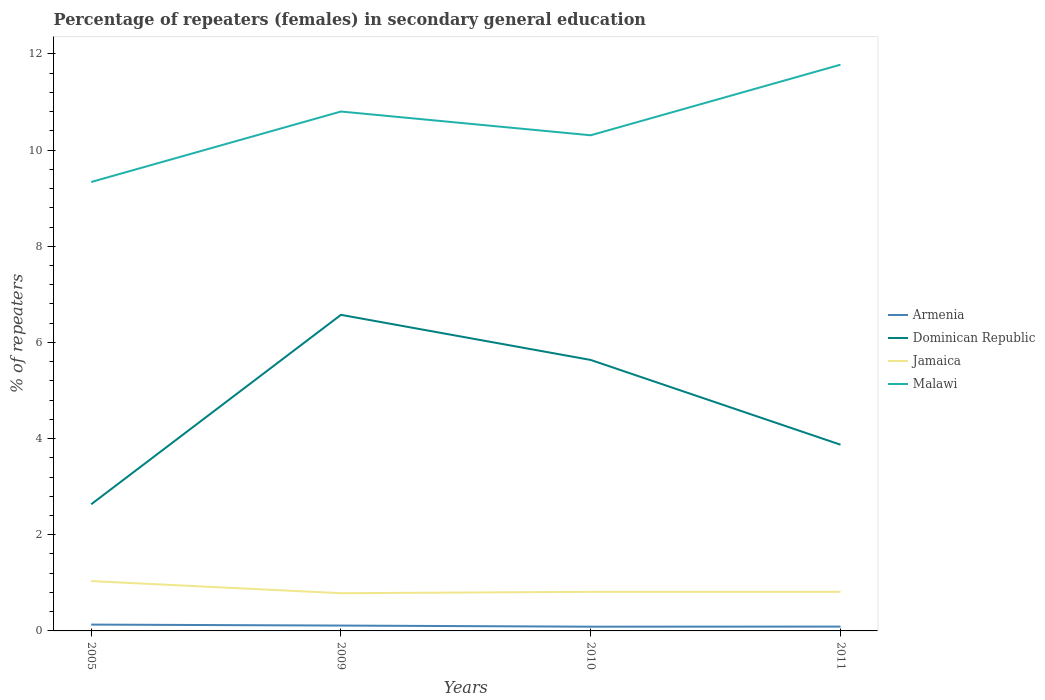Is the number of lines equal to the number of legend labels?
Your answer should be very brief. Yes. Across all years, what is the maximum percentage of female repeaters in Jamaica?
Your answer should be very brief. 0.78. What is the difference between the highest and the second highest percentage of female repeaters in Jamaica?
Provide a succinct answer. 0.25. What is the difference between the highest and the lowest percentage of female repeaters in Jamaica?
Make the answer very short. 1. Is the percentage of female repeaters in Dominican Republic strictly greater than the percentage of female repeaters in Malawi over the years?
Provide a short and direct response. Yes. How many lines are there?
Your answer should be compact. 4. What is the difference between two consecutive major ticks on the Y-axis?
Your answer should be compact. 2. Are the values on the major ticks of Y-axis written in scientific E-notation?
Offer a terse response. No. Does the graph contain grids?
Give a very brief answer. No. Where does the legend appear in the graph?
Make the answer very short. Center right. How many legend labels are there?
Provide a succinct answer. 4. What is the title of the graph?
Make the answer very short. Percentage of repeaters (females) in secondary general education. Does "Bosnia and Herzegovina" appear as one of the legend labels in the graph?
Provide a succinct answer. No. What is the label or title of the Y-axis?
Offer a very short reply. % of repeaters. What is the % of repeaters in Armenia in 2005?
Provide a succinct answer. 0.13. What is the % of repeaters of Dominican Republic in 2005?
Provide a short and direct response. 2.63. What is the % of repeaters in Jamaica in 2005?
Offer a terse response. 1.04. What is the % of repeaters in Malawi in 2005?
Your response must be concise. 9.34. What is the % of repeaters of Armenia in 2009?
Offer a terse response. 0.11. What is the % of repeaters of Dominican Republic in 2009?
Offer a very short reply. 6.57. What is the % of repeaters of Jamaica in 2009?
Keep it short and to the point. 0.78. What is the % of repeaters of Malawi in 2009?
Ensure brevity in your answer.  10.8. What is the % of repeaters in Armenia in 2010?
Keep it short and to the point. 0.09. What is the % of repeaters of Dominican Republic in 2010?
Your answer should be compact. 5.64. What is the % of repeaters of Jamaica in 2010?
Offer a very short reply. 0.81. What is the % of repeaters in Malawi in 2010?
Offer a terse response. 10.31. What is the % of repeaters of Armenia in 2011?
Your answer should be compact. 0.09. What is the % of repeaters in Dominican Republic in 2011?
Your answer should be very brief. 3.87. What is the % of repeaters in Jamaica in 2011?
Ensure brevity in your answer.  0.81. What is the % of repeaters of Malawi in 2011?
Keep it short and to the point. 11.78. Across all years, what is the maximum % of repeaters in Armenia?
Your response must be concise. 0.13. Across all years, what is the maximum % of repeaters in Dominican Republic?
Keep it short and to the point. 6.57. Across all years, what is the maximum % of repeaters of Jamaica?
Offer a very short reply. 1.04. Across all years, what is the maximum % of repeaters of Malawi?
Offer a very short reply. 11.78. Across all years, what is the minimum % of repeaters in Armenia?
Make the answer very short. 0.09. Across all years, what is the minimum % of repeaters in Dominican Republic?
Your answer should be very brief. 2.63. Across all years, what is the minimum % of repeaters in Jamaica?
Provide a succinct answer. 0.78. Across all years, what is the minimum % of repeaters of Malawi?
Your answer should be compact. 9.34. What is the total % of repeaters in Armenia in the graph?
Provide a succinct answer. 0.42. What is the total % of repeaters of Dominican Republic in the graph?
Make the answer very short. 18.72. What is the total % of repeaters in Jamaica in the graph?
Make the answer very short. 3.45. What is the total % of repeaters of Malawi in the graph?
Ensure brevity in your answer.  42.22. What is the difference between the % of repeaters in Dominican Republic in 2005 and that in 2009?
Offer a terse response. -3.94. What is the difference between the % of repeaters of Jamaica in 2005 and that in 2009?
Offer a very short reply. 0.25. What is the difference between the % of repeaters of Malawi in 2005 and that in 2009?
Make the answer very short. -1.47. What is the difference between the % of repeaters in Armenia in 2005 and that in 2010?
Provide a short and direct response. 0.04. What is the difference between the % of repeaters of Dominican Republic in 2005 and that in 2010?
Keep it short and to the point. -3. What is the difference between the % of repeaters of Jamaica in 2005 and that in 2010?
Make the answer very short. 0.22. What is the difference between the % of repeaters of Malawi in 2005 and that in 2010?
Make the answer very short. -0.97. What is the difference between the % of repeaters in Armenia in 2005 and that in 2011?
Ensure brevity in your answer.  0.04. What is the difference between the % of repeaters of Dominican Republic in 2005 and that in 2011?
Offer a very short reply. -1.24. What is the difference between the % of repeaters in Jamaica in 2005 and that in 2011?
Provide a short and direct response. 0.22. What is the difference between the % of repeaters in Malawi in 2005 and that in 2011?
Keep it short and to the point. -2.44. What is the difference between the % of repeaters of Armenia in 2009 and that in 2010?
Your response must be concise. 0.02. What is the difference between the % of repeaters in Dominican Republic in 2009 and that in 2010?
Your response must be concise. 0.94. What is the difference between the % of repeaters of Jamaica in 2009 and that in 2010?
Ensure brevity in your answer.  -0.03. What is the difference between the % of repeaters of Malawi in 2009 and that in 2010?
Your answer should be compact. 0.49. What is the difference between the % of repeaters of Armenia in 2009 and that in 2011?
Your answer should be compact. 0.02. What is the difference between the % of repeaters in Dominican Republic in 2009 and that in 2011?
Give a very brief answer. 2.7. What is the difference between the % of repeaters in Jamaica in 2009 and that in 2011?
Your answer should be compact. -0.03. What is the difference between the % of repeaters of Malawi in 2009 and that in 2011?
Your answer should be very brief. -0.97. What is the difference between the % of repeaters in Armenia in 2010 and that in 2011?
Provide a short and direct response. -0. What is the difference between the % of repeaters of Dominican Republic in 2010 and that in 2011?
Keep it short and to the point. 1.76. What is the difference between the % of repeaters in Jamaica in 2010 and that in 2011?
Your answer should be very brief. 0. What is the difference between the % of repeaters in Malawi in 2010 and that in 2011?
Your answer should be compact. -1.47. What is the difference between the % of repeaters of Armenia in 2005 and the % of repeaters of Dominican Republic in 2009?
Your answer should be very brief. -6.44. What is the difference between the % of repeaters of Armenia in 2005 and the % of repeaters of Jamaica in 2009?
Provide a succinct answer. -0.65. What is the difference between the % of repeaters of Armenia in 2005 and the % of repeaters of Malawi in 2009?
Provide a short and direct response. -10.67. What is the difference between the % of repeaters in Dominican Republic in 2005 and the % of repeaters in Jamaica in 2009?
Offer a terse response. 1.85. What is the difference between the % of repeaters in Dominican Republic in 2005 and the % of repeaters in Malawi in 2009?
Give a very brief answer. -8.17. What is the difference between the % of repeaters in Jamaica in 2005 and the % of repeaters in Malawi in 2009?
Keep it short and to the point. -9.77. What is the difference between the % of repeaters of Armenia in 2005 and the % of repeaters of Dominican Republic in 2010?
Give a very brief answer. -5.5. What is the difference between the % of repeaters in Armenia in 2005 and the % of repeaters in Jamaica in 2010?
Your answer should be compact. -0.68. What is the difference between the % of repeaters in Armenia in 2005 and the % of repeaters in Malawi in 2010?
Offer a terse response. -10.18. What is the difference between the % of repeaters of Dominican Republic in 2005 and the % of repeaters of Jamaica in 2010?
Ensure brevity in your answer.  1.82. What is the difference between the % of repeaters of Dominican Republic in 2005 and the % of repeaters of Malawi in 2010?
Your answer should be very brief. -7.67. What is the difference between the % of repeaters of Jamaica in 2005 and the % of repeaters of Malawi in 2010?
Ensure brevity in your answer.  -9.27. What is the difference between the % of repeaters in Armenia in 2005 and the % of repeaters in Dominican Republic in 2011?
Your answer should be compact. -3.74. What is the difference between the % of repeaters in Armenia in 2005 and the % of repeaters in Jamaica in 2011?
Offer a terse response. -0.68. What is the difference between the % of repeaters of Armenia in 2005 and the % of repeaters of Malawi in 2011?
Provide a succinct answer. -11.64. What is the difference between the % of repeaters of Dominican Republic in 2005 and the % of repeaters of Jamaica in 2011?
Offer a terse response. 1.82. What is the difference between the % of repeaters of Dominican Republic in 2005 and the % of repeaters of Malawi in 2011?
Make the answer very short. -9.14. What is the difference between the % of repeaters in Jamaica in 2005 and the % of repeaters in Malawi in 2011?
Make the answer very short. -10.74. What is the difference between the % of repeaters of Armenia in 2009 and the % of repeaters of Dominican Republic in 2010?
Keep it short and to the point. -5.52. What is the difference between the % of repeaters of Armenia in 2009 and the % of repeaters of Jamaica in 2010?
Give a very brief answer. -0.7. What is the difference between the % of repeaters in Armenia in 2009 and the % of repeaters in Malawi in 2010?
Your answer should be compact. -10.2. What is the difference between the % of repeaters in Dominican Republic in 2009 and the % of repeaters in Jamaica in 2010?
Give a very brief answer. 5.76. What is the difference between the % of repeaters in Dominican Republic in 2009 and the % of repeaters in Malawi in 2010?
Give a very brief answer. -3.73. What is the difference between the % of repeaters of Jamaica in 2009 and the % of repeaters of Malawi in 2010?
Offer a terse response. -9.52. What is the difference between the % of repeaters in Armenia in 2009 and the % of repeaters in Dominican Republic in 2011?
Your answer should be compact. -3.76. What is the difference between the % of repeaters of Armenia in 2009 and the % of repeaters of Jamaica in 2011?
Make the answer very short. -0.7. What is the difference between the % of repeaters in Armenia in 2009 and the % of repeaters in Malawi in 2011?
Your answer should be very brief. -11.66. What is the difference between the % of repeaters of Dominican Republic in 2009 and the % of repeaters of Jamaica in 2011?
Offer a very short reply. 5.76. What is the difference between the % of repeaters in Dominican Republic in 2009 and the % of repeaters in Malawi in 2011?
Your answer should be compact. -5.2. What is the difference between the % of repeaters of Jamaica in 2009 and the % of repeaters of Malawi in 2011?
Your answer should be very brief. -10.99. What is the difference between the % of repeaters of Armenia in 2010 and the % of repeaters of Dominican Republic in 2011?
Keep it short and to the point. -3.79. What is the difference between the % of repeaters of Armenia in 2010 and the % of repeaters of Jamaica in 2011?
Your answer should be very brief. -0.72. What is the difference between the % of repeaters of Armenia in 2010 and the % of repeaters of Malawi in 2011?
Provide a succinct answer. -11.69. What is the difference between the % of repeaters of Dominican Republic in 2010 and the % of repeaters of Jamaica in 2011?
Your answer should be very brief. 4.82. What is the difference between the % of repeaters in Dominican Republic in 2010 and the % of repeaters in Malawi in 2011?
Keep it short and to the point. -6.14. What is the difference between the % of repeaters of Jamaica in 2010 and the % of repeaters of Malawi in 2011?
Offer a very short reply. -10.96. What is the average % of repeaters in Armenia per year?
Your answer should be very brief. 0.11. What is the average % of repeaters in Dominican Republic per year?
Keep it short and to the point. 4.68. What is the average % of repeaters of Jamaica per year?
Keep it short and to the point. 0.86. What is the average % of repeaters in Malawi per year?
Give a very brief answer. 10.56. In the year 2005, what is the difference between the % of repeaters of Armenia and % of repeaters of Dominican Republic?
Keep it short and to the point. -2.5. In the year 2005, what is the difference between the % of repeaters of Armenia and % of repeaters of Jamaica?
Offer a very short reply. -0.9. In the year 2005, what is the difference between the % of repeaters of Armenia and % of repeaters of Malawi?
Offer a very short reply. -9.2. In the year 2005, what is the difference between the % of repeaters in Dominican Republic and % of repeaters in Jamaica?
Your answer should be very brief. 1.6. In the year 2005, what is the difference between the % of repeaters of Dominican Republic and % of repeaters of Malawi?
Your answer should be very brief. -6.7. In the year 2005, what is the difference between the % of repeaters of Jamaica and % of repeaters of Malawi?
Offer a terse response. -8.3. In the year 2009, what is the difference between the % of repeaters in Armenia and % of repeaters in Dominican Republic?
Your answer should be compact. -6.46. In the year 2009, what is the difference between the % of repeaters in Armenia and % of repeaters in Jamaica?
Make the answer very short. -0.67. In the year 2009, what is the difference between the % of repeaters of Armenia and % of repeaters of Malawi?
Ensure brevity in your answer.  -10.69. In the year 2009, what is the difference between the % of repeaters of Dominican Republic and % of repeaters of Jamaica?
Your answer should be very brief. 5.79. In the year 2009, what is the difference between the % of repeaters in Dominican Republic and % of repeaters in Malawi?
Ensure brevity in your answer.  -4.23. In the year 2009, what is the difference between the % of repeaters in Jamaica and % of repeaters in Malawi?
Offer a terse response. -10.02. In the year 2010, what is the difference between the % of repeaters of Armenia and % of repeaters of Dominican Republic?
Provide a succinct answer. -5.55. In the year 2010, what is the difference between the % of repeaters in Armenia and % of repeaters in Jamaica?
Ensure brevity in your answer.  -0.72. In the year 2010, what is the difference between the % of repeaters in Armenia and % of repeaters in Malawi?
Your answer should be compact. -10.22. In the year 2010, what is the difference between the % of repeaters of Dominican Republic and % of repeaters of Jamaica?
Keep it short and to the point. 4.82. In the year 2010, what is the difference between the % of repeaters in Dominican Republic and % of repeaters in Malawi?
Make the answer very short. -4.67. In the year 2010, what is the difference between the % of repeaters in Jamaica and % of repeaters in Malawi?
Offer a very short reply. -9.5. In the year 2011, what is the difference between the % of repeaters of Armenia and % of repeaters of Dominican Republic?
Your answer should be compact. -3.78. In the year 2011, what is the difference between the % of repeaters of Armenia and % of repeaters of Jamaica?
Your response must be concise. -0.72. In the year 2011, what is the difference between the % of repeaters in Armenia and % of repeaters in Malawi?
Provide a succinct answer. -11.69. In the year 2011, what is the difference between the % of repeaters of Dominican Republic and % of repeaters of Jamaica?
Ensure brevity in your answer.  3.06. In the year 2011, what is the difference between the % of repeaters in Dominican Republic and % of repeaters in Malawi?
Give a very brief answer. -7.9. In the year 2011, what is the difference between the % of repeaters in Jamaica and % of repeaters in Malawi?
Your answer should be very brief. -10.96. What is the ratio of the % of repeaters of Armenia in 2005 to that in 2009?
Your answer should be very brief. 1.18. What is the ratio of the % of repeaters in Dominican Republic in 2005 to that in 2009?
Offer a terse response. 0.4. What is the ratio of the % of repeaters in Jamaica in 2005 to that in 2009?
Give a very brief answer. 1.32. What is the ratio of the % of repeaters of Malawi in 2005 to that in 2009?
Your answer should be compact. 0.86. What is the ratio of the % of repeaters in Armenia in 2005 to that in 2010?
Ensure brevity in your answer.  1.5. What is the ratio of the % of repeaters of Dominican Republic in 2005 to that in 2010?
Your response must be concise. 0.47. What is the ratio of the % of repeaters of Jamaica in 2005 to that in 2010?
Your response must be concise. 1.27. What is the ratio of the % of repeaters of Malawi in 2005 to that in 2010?
Your answer should be very brief. 0.91. What is the ratio of the % of repeaters of Armenia in 2005 to that in 2011?
Your answer should be compact. 1.46. What is the ratio of the % of repeaters in Dominican Republic in 2005 to that in 2011?
Give a very brief answer. 0.68. What is the ratio of the % of repeaters in Jamaica in 2005 to that in 2011?
Provide a short and direct response. 1.27. What is the ratio of the % of repeaters in Malawi in 2005 to that in 2011?
Give a very brief answer. 0.79. What is the ratio of the % of repeaters in Armenia in 2009 to that in 2010?
Provide a succinct answer. 1.27. What is the ratio of the % of repeaters in Dominican Republic in 2009 to that in 2010?
Ensure brevity in your answer.  1.17. What is the ratio of the % of repeaters in Jamaica in 2009 to that in 2010?
Your response must be concise. 0.96. What is the ratio of the % of repeaters of Malawi in 2009 to that in 2010?
Ensure brevity in your answer.  1.05. What is the ratio of the % of repeaters of Armenia in 2009 to that in 2011?
Ensure brevity in your answer.  1.24. What is the ratio of the % of repeaters of Dominican Republic in 2009 to that in 2011?
Ensure brevity in your answer.  1.7. What is the ratio of the % of repeaters in Jamaica in 2009 to that in 2011?
Offer a terse response. 0.96. What is the ratio of the % of repeaters of Malawi in 2009 to that in 2011?
Your response must be concise. 0.92. What is the ratio of the % of repeaters in Armenia in 2010 to that in 2011?
Your answer should be compact. 0.98. What is the ratio of the % of repeaters in Dominican Republic in 2010 to that in 2011?
Your answer should be compact. 1.46. What is the ratio of the % of repeaters of Jamaica in 2010 to that in 2011?
Offer a terse response. 1. What is the ratio of the % of repeaters in Malawi in 2010 to that in 2011?
Offer a terse response. 0.88. What is the difference between the highest and the second highest % of repeaters of Dominican Republic?
Give a very brief answer. 0.94. What is the difference between the highest and the second highest % of repeaters of Jamaica?
Give a very brief answer. 0.22. What is the difference between the highest and the second highest % of repeaters in Malawi?
Give a very brief answer. 0.97. What is the difference between the highest and the lowest % of repeaters in Armenia?
Keep it short and to the point. 0.04. What is the difference between the highest and the lowest % of repeaters of Dominican Republic?
Provide a short and direct response. 3.94. What is the difference between the highest and the lowest % of repeaters in Jamaica?
Your response must be concise. 0.25. What is the difference between the highest and the lowest % of repeaters in Malawi?
Keep it short and to the point. 2.44. 